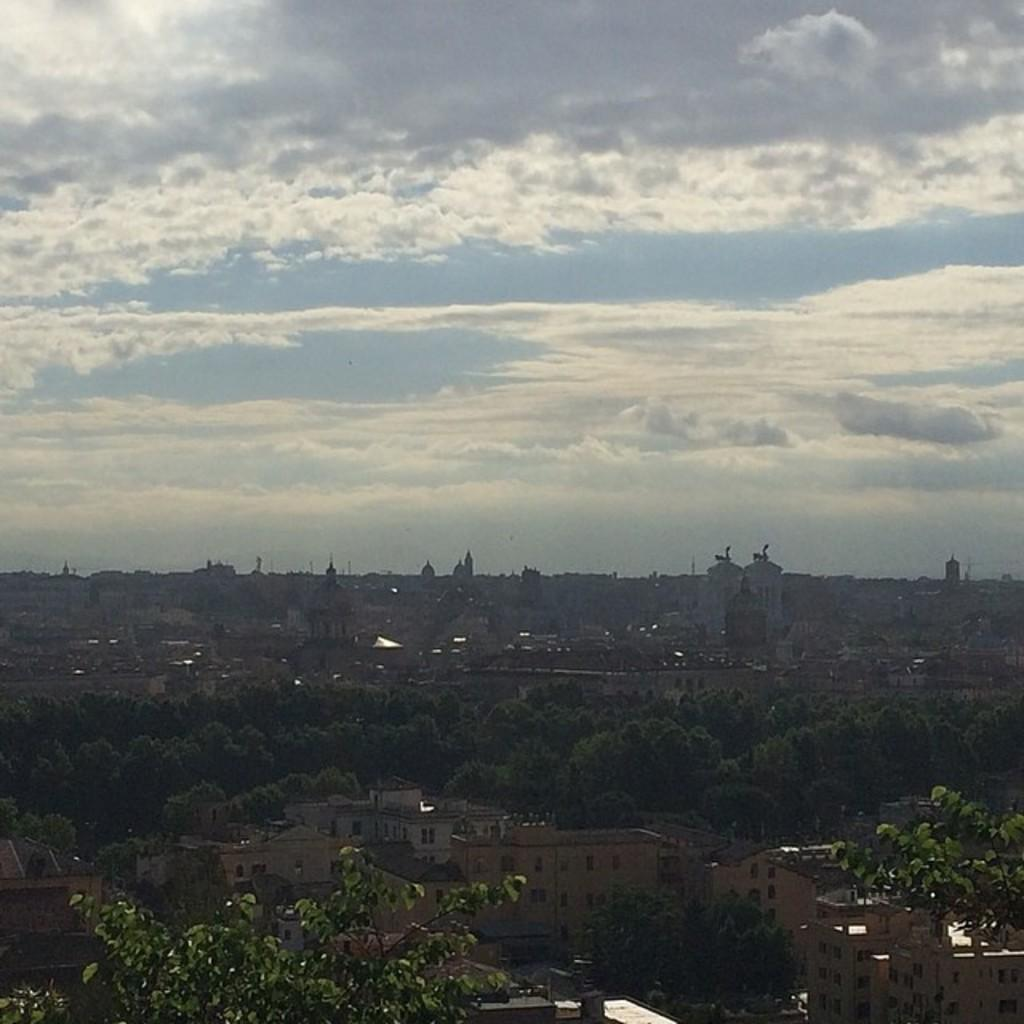What type of structures are visible in the image? There are buildings with windows in the image. Are there any tall structures in the image? Yes, there are towers in the image. What type of vegetation is present in the image? There is a group of trees in the image. How would you describe the sky in the image? The sky is cloudy in the image. How many cows are grazing in the image? There are no cows present in the image. What type of quiver is being used by the person in the image? There is no person or quiver visible in the image. 